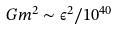Convert formula to latex. <formula><loc_0><loc_0><loc_500><loc_500>G m ^ { 2 } \sim \epsilon ^ { 2 } / 1 0 ^ { 4 0 }</formula> 